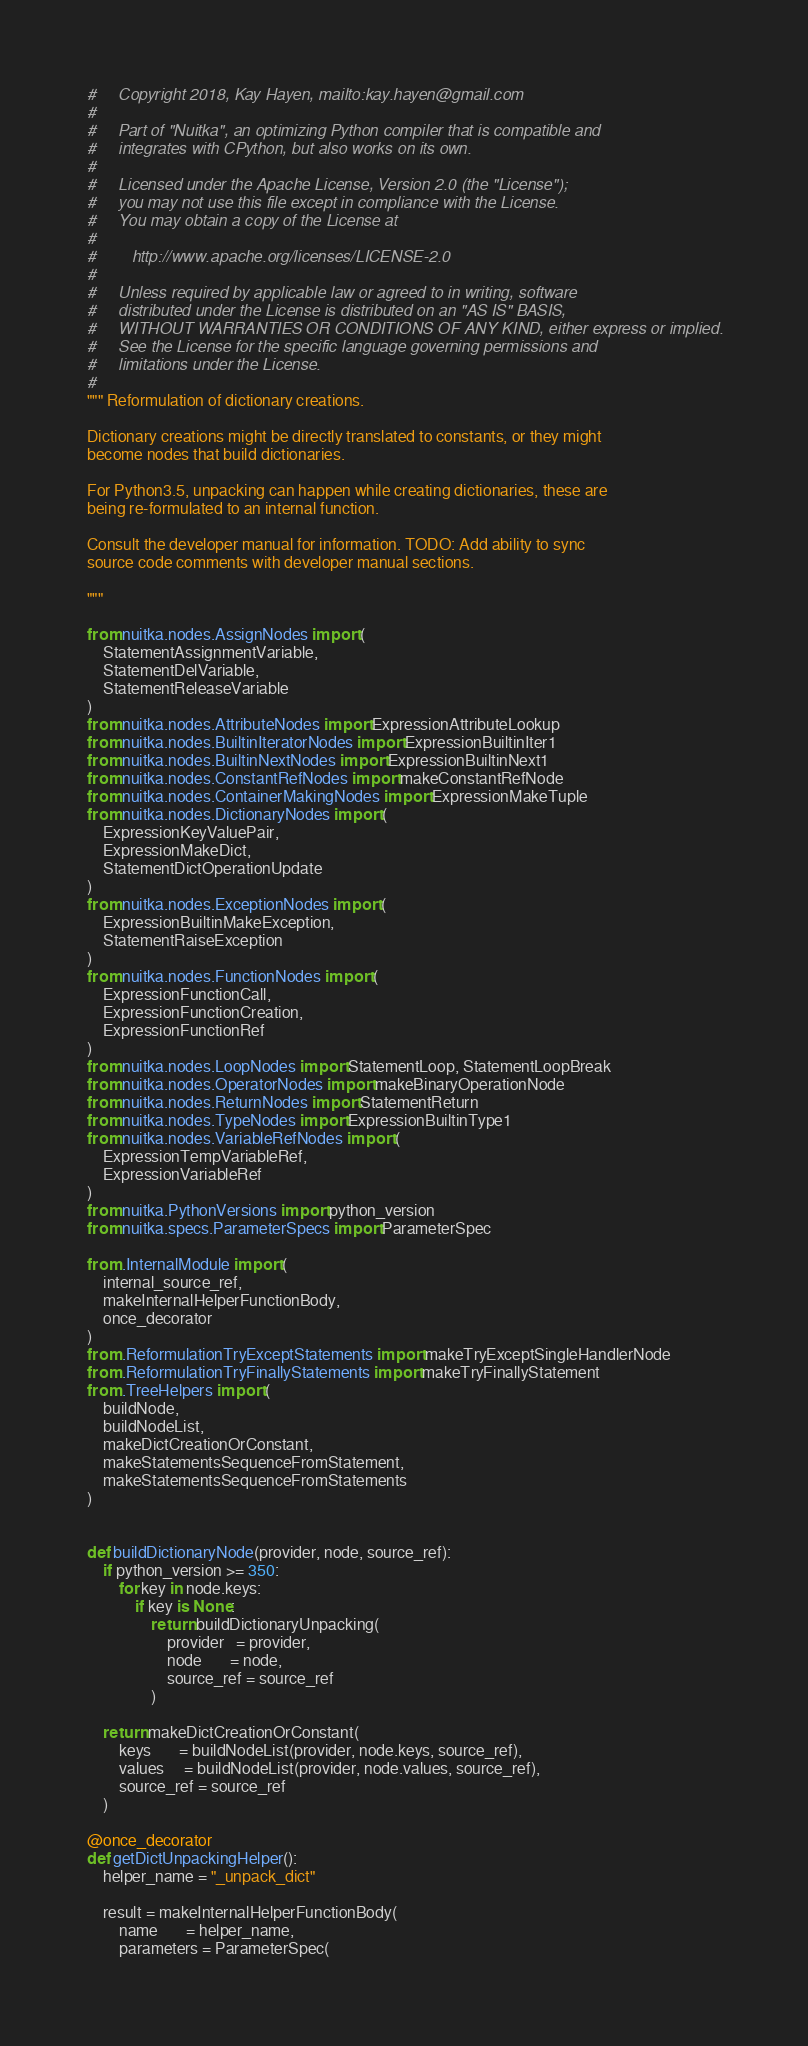Convert code to text. <code><loc_0><loc_0><loc_500><loc_500><_Python_>#     Copyright 2018, Kay Hayen, mailto:kay.hayen@gmail.com
#
#     Part of "Nuitka", an optimizing Python compiler that is compatible and
#     integrates with CPython, but also works on its own.
#
#     Licensed under the Apache License, Version 2.0 (the "License");
#     you may not use this file except in compliance with the License.
#     You may obtain a copy of the License at
#
#        http://www.apache.org/licenses/LICENSE-2.0
#
#     Unless required by applicable law or agreed to in writing, software
#     distributed under the License is distributed on an "AS IS" BASIS,
#     WITHOUT WARRANTIES OR CONDITIONS OF ANY KIND, either express or implied.
#     See the License for the specific language governing permissions and
#     limitations under the License.
#
""" Reformulation of dictionary creations.

Dictionary creations might be directly translated to constants, or they might
become nodes that build dictionaries.

For Python3.5, unpacking can happen while creating dictionaries, these are
being re-formulated to an internal function.

Consult the developer manual for information. TODO: Add ability to sync
source code comments with developer manual sections.

"""

from nuitka.nodes.AssignNodes import (
    StatementAssignmentVariable,
    StatementDelVariable,
    StatementReleaseVariable
)
from nuitka.nodes.AttributeNodes import ExpressionAttributeLookup
from nuitka.nodes.BuiltinIteratorNodes import ExpressionBuiltinIter1
from nuitka.nodes.BuiltinNextNodes import ExpressionBuiltinNext1
from nuitka.nodes.ConstantRefNodes import makeConstantRefNode
from nuitka.nodes.ContainerMakingNodes import ExpressionMakeTuple
from nuitka.nodes.DictionaryNodes import (
    ExpressionKeyValuePair,
    ExpressionMakeDict,
    StatementDictOperationUpdate
)
from nuitka.nodes.ExceptionNodes import (
    ExpressionBuiltinMakeException,
    StatementRaiseException
)
from nuitka.nodes.FunctionNodes import (
    ExpressionFunctionCall,
    ExpressionFunctionCreation,
    ExpressionFunctionRef
)
from nuitka.nodes.LoopNodes import StatementLoop, StatementLoopBreak
from nuitka.nodes.OperatorNodes import makeBinaryOperationNode
from nuitka.nodes.ReturnNodes import StatementReturn
from nuitka.nodes.TypeNodes import ExpressionBuiltinType1
from nuitka.nodes.VariableRefNodes import (
    ExpressionTempVariableRef,
    ExpressionVariableRef
)
from nuitka.PythonVersions import python_version
from nuitka.specs.ParameterSpecs import ParameterSpec

from .InternalModule import (
    internal_source_ref,
    makeInternalHelperFunctionBody,
    once_decorator
)
from .ReformulationTryExceptStatements import makeTryExceptSingleHandlerNode
from .ReformulationTryFinallyStatements import makeTryFinallyStatement
from .TreeHelpers import (
    buildNode,
    buildNodeList,
    makeDictCreationOrConstant,
    makeStatementsSequenceFromStatement,
    makeStatementsSequenceFromStatements
)


def buildDictionaryNode(provider, node, source_ref):
    if python_version >= 350:
        for key in node.keys:
            if key is None:
                return buildDictionaryUnpacking(
                    provider   = provider,
                    node       = node,
                    source_ref = source_ref
                )

    return makeDictCreationOrConstant(
        keys       = buildNodeList(provider, node.keys, source_ref),
        values     = buildNodeList(provider, node.values, source_ref),
        source_ref = source_ref
    )

@once_decorator
def getDictUnpackingHelper():
    helper_name = "_unpack_dict"

    result = makeInternalHelperFunctionBody(
        name       = helper_name,
        parameters = ParameterSpec(</code> 